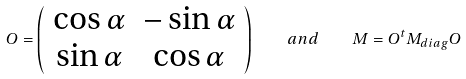<formula> <loc_0><loc_0><loc_500><loc_500>O = \left ( \begin{array} { c c } { \cos \alpha } & { - \sin \alpha } \\ { \sin \alpha } & { \cos \alpha } \end{array} \right ) \quad a n d \quad M = O ^ { t } M _ { d i a g } O</formula> 